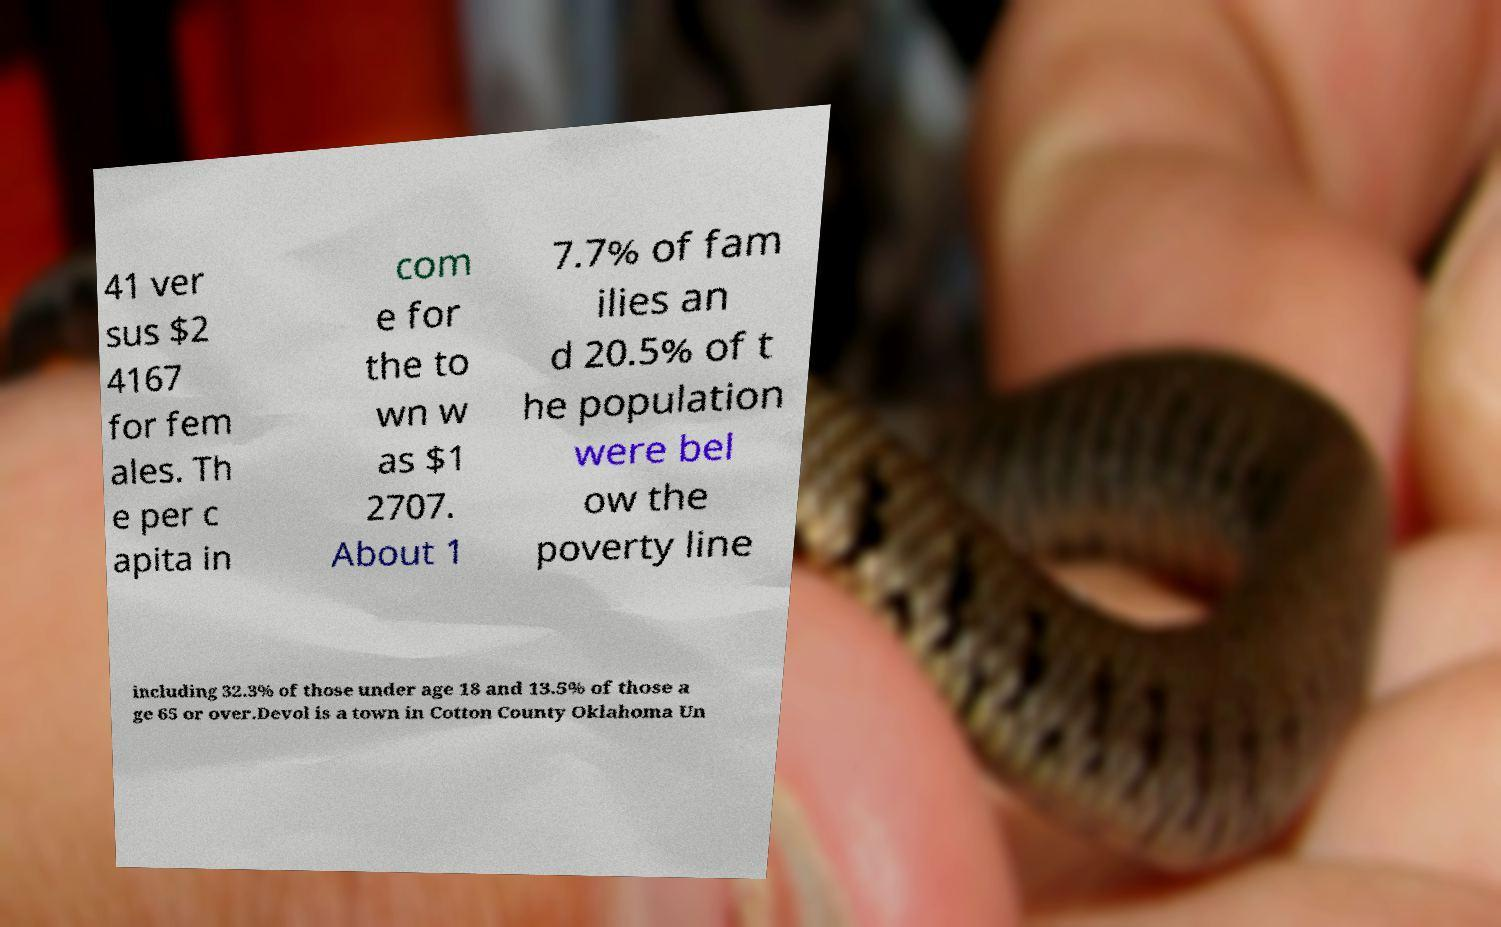Can you accurately transcribe the text from the provided image for me? 41 ver sus $2 4167 for fem ales. Th e per c apita in com e for the to wn w as $1 2707. About 1 7.7% of fam ilies an d 20.5% of t he population were bel ow the poverty line including 32.3% of those under age 18 and 13.5% of those a ge 65 or over.Devol is a town in Cotton County Oklahoma Un 